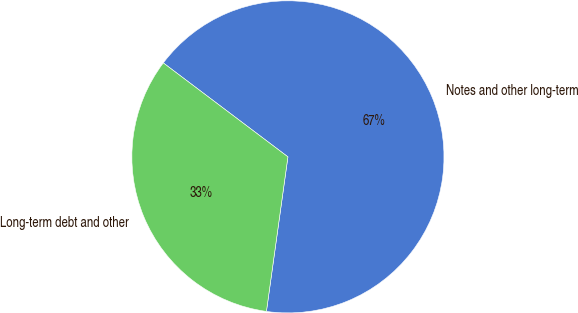Convert chart to OTSL. <chart><loc_0><loc_0><loc_500><loc_500><pie_chart><fcel>Notes and other long-term<fcel>Long-term debt and other<nl><fcel>66.92%<fcel>33.08%<nl></chart> 